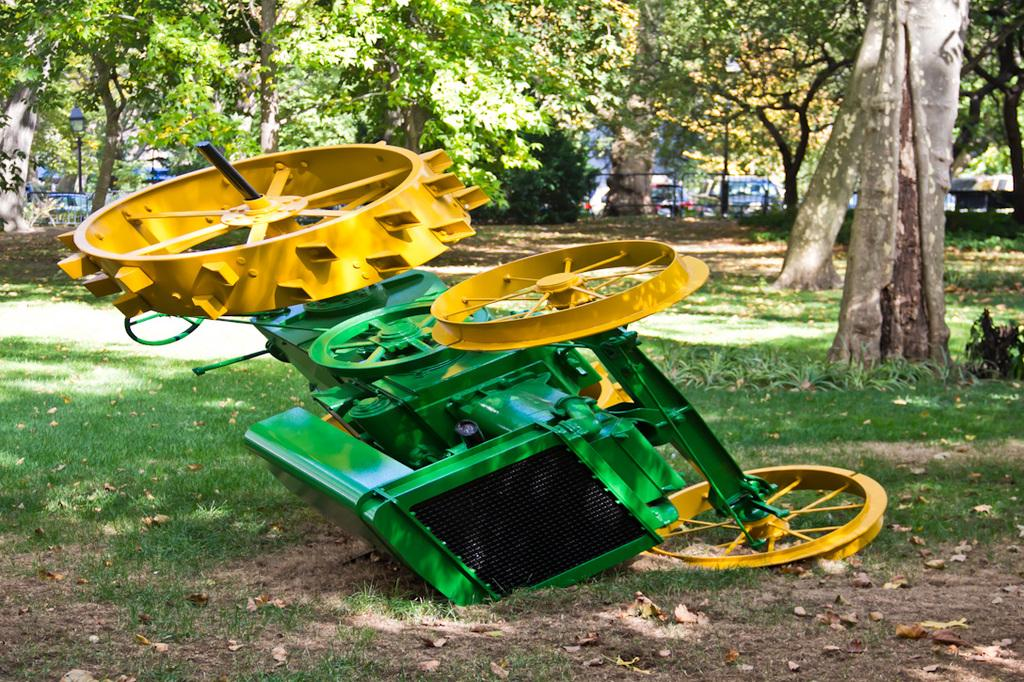What is the main subject in the foreground of the image? There is a vehicle in the foreground of the image. What is the condition of the vehicle in the image? The vehicle has fallen down onto the ground. What type of natural environment is visible in the background of the image? There is grass, trees, and poles in the background of the image. Are there any other vehicles visible in the image? Yes, there are vehicles in the background of the image. What type of structure can be seen in the background of the image? There is a railing in the background of the image. What type of egg is being used to hold the fork in the image? There is no egg or fork present in the image. How many quarters can be seen on the railing in the image? There are no quarters visible on the railing in the image. 